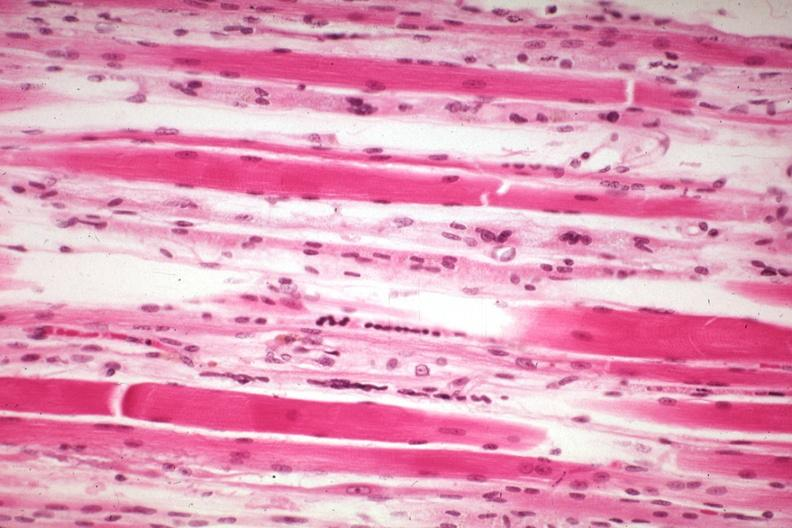s soft tissue present?
Answer the question using a single word or phrase. Yes 